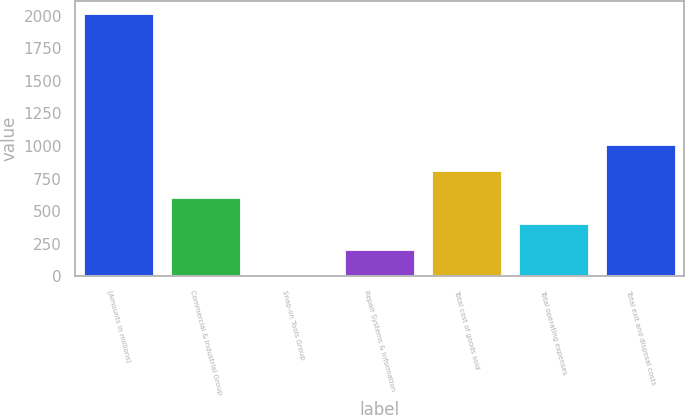Convert chart. <chart><loc_0><loc_0><loc_500><loc_500><bar_chart><fcel>(Amounts in millions)<fcel>Commercial & Industrial Group<fcel>Snap-on Tools Group<fcel>Repair Systems & Information<fcel>Total cost of goods sold<fcel>Total operating expenses<fcel>Total exit and disposal costs<nl><fcel>2013<fcel>604.04<fcel>0.2<fcel>201.48<fcel>805.32<fcel>402.76<fcel>1006.6<nl></chart> 